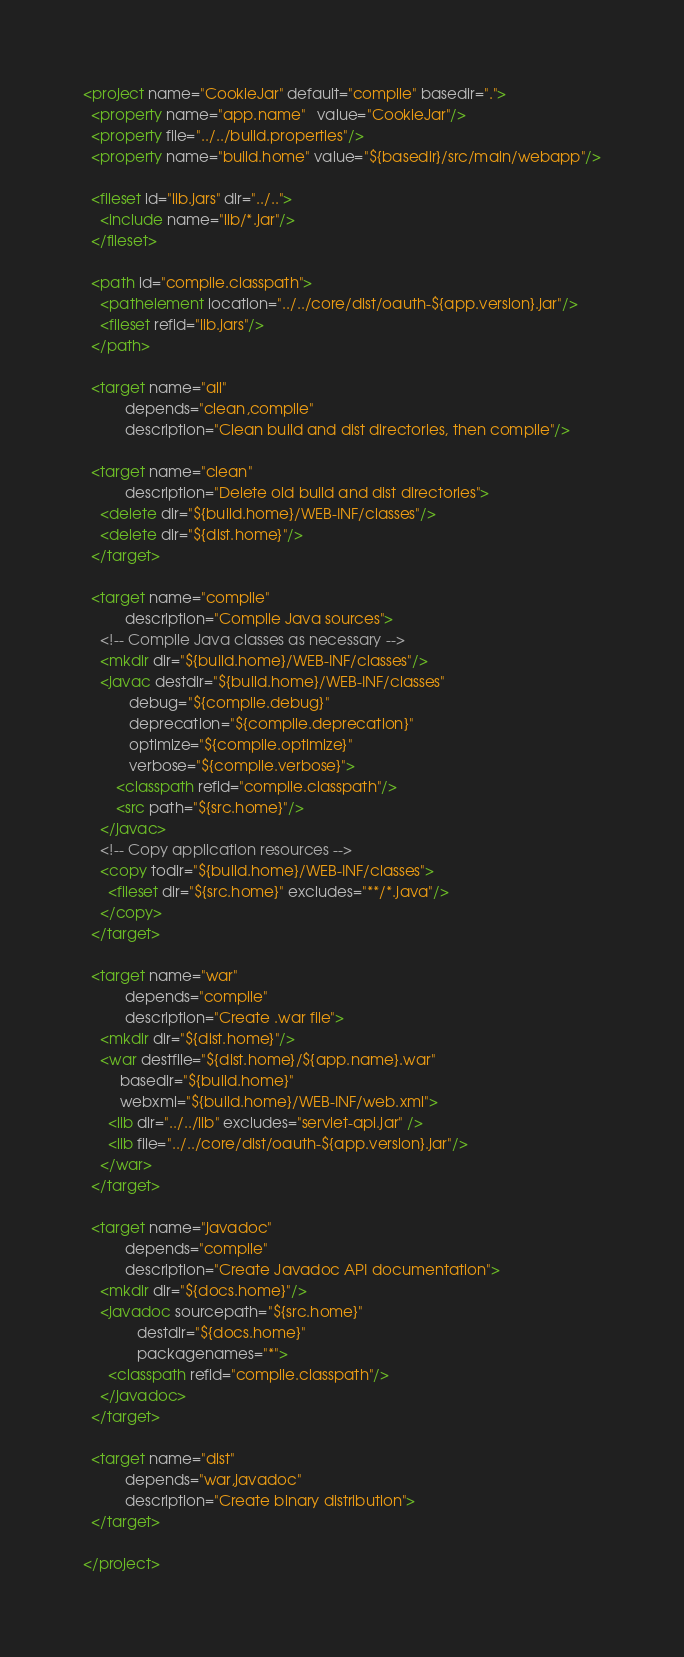Convert code to text. <code><loc_0><loc_0><loc_500><loc_500><_XML_><project name="CookieJar" default="compile" basedir=".">
  <property name="app.name"   value="CookieJar"/>
  <property file="../../build.properties"/>
  <property name="build.home" value="${basedir}/src/main/webapp"/>

  <fileset id="lib.jars" dir="../..">
    <include name="lib/*.jar"/>
  </fileset>

  <path id="compile.classpath">
    <pathelement location="../../core/dist/oauth-${app.version}.jar"/>
    <fileset refid="lib.jars"/>
  </path>

  <target name="all"
          depends="clean,compile"
          description="Clean build and dist directories, then compile"/>

  <target name="clean"
          description="Delete old build and dist directories">
    <delete dir="${build.home}/WEB-INF/classes"/>
    <delete dir="${dist.home}"/>
  </target>

  <target name="compile"
          description="Compile Java sources">
    <!-- Compile Java classes as necessary -->
    <mkdir dir="${build.home}/WEB-INF/classes"/>
    <javac destdir="${build.home}/WEB-INF/classes"
           debug="${compile.debug}"
           deprecation="${compile.deprecation}"
           optimize="${compile.optimize}"
           verbose="${compile.verbose}">
        <classpath refid="compile.classpath"/>
        <src path="${src.home}"/>
    </javac>
    <!-- Copy application resources -->
    <copy todir="${build.home}/WEB-INF/classes">
      <fileset dir="${src.home}" excludes="**/*.java"/>
    </copy>
  </target>

  <target name="war"
          depends="compile"
          description="Create .war file">
    <mkdir dir="${dist.home}"/>
    <war destfile="${dist.home}/${app.name}.war"
         basedir="${build.home}"
         webxml="${build.home}/WEB-INF/web.xml">
      <lib dir="../../lib" excludes="servlet-api.jar" />
      <lib file="../../core/dist/oauth-${app.version}.jar"/>
    </war>
  </target>

  <target name="javadoc"
          depends="compile"
          description="Create Javadoc API documentation">
    <mkdir dir="${docs.home}"/>
    <javadoc sourcepath="${src.home}"
             destdir="${docs.home}"
             packagenames="*">
      <classpath refid="compile.classpath"/>
    </javadoc>
  </target>

  <target name="dist"
          depends="war,javadoc"
          description="Create binary distribution">
  </target>

</project>
</code> 